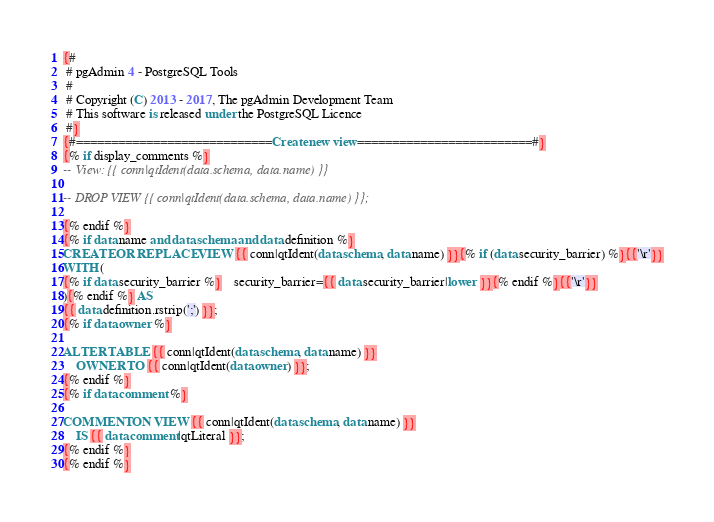<code> <loc_0><loc_0><loc_500><loc_500><_SQL_>{#
 # pgAdmin 4 - PostgreSQL Tools
 #
 # Copyright (C) 2013 - 2017, The pgAdmin Development Team
 # This software is released under the PostgreSQL Licence
 #}
{#============================Create new view=========================#}
{% if display_comments %}
-- View: {{ conn|qtIdent(data.schema, data.name) }}

-- DROP VIEW {{ conn|qtIdent(data.schema, data.name) }};

{% endif %}
{% if data.name and data.schema and data.definition %}
CREATE OR REPLACE VIEW {{ conn|qtIdent(data.schema, data.name) }}{% if (data.security_barrier) %}{{'\r'}}
WITH (
{% if data.security_barrier %}    security_barrier={{ data.security_barrier|lower }}{% endif %}{{'\r'}}
){% endif %} AS
{{ data.definition.rstrip(';') }};
{% if data.owner %}

ALTER TABLE {{ conn|qtIdent(data.schema, data.name) }}
    OWNER TO {{ conn|qtIdent(data.owner) }};
{% endif %}
{% if data.comment %}

COMMENT ON VIEW {{ conn|qtIdent(data.schema, data.name) }}
    IS {{ data.comment|qtLiteral }};
{% endif %}
{% endif %}
</code> 